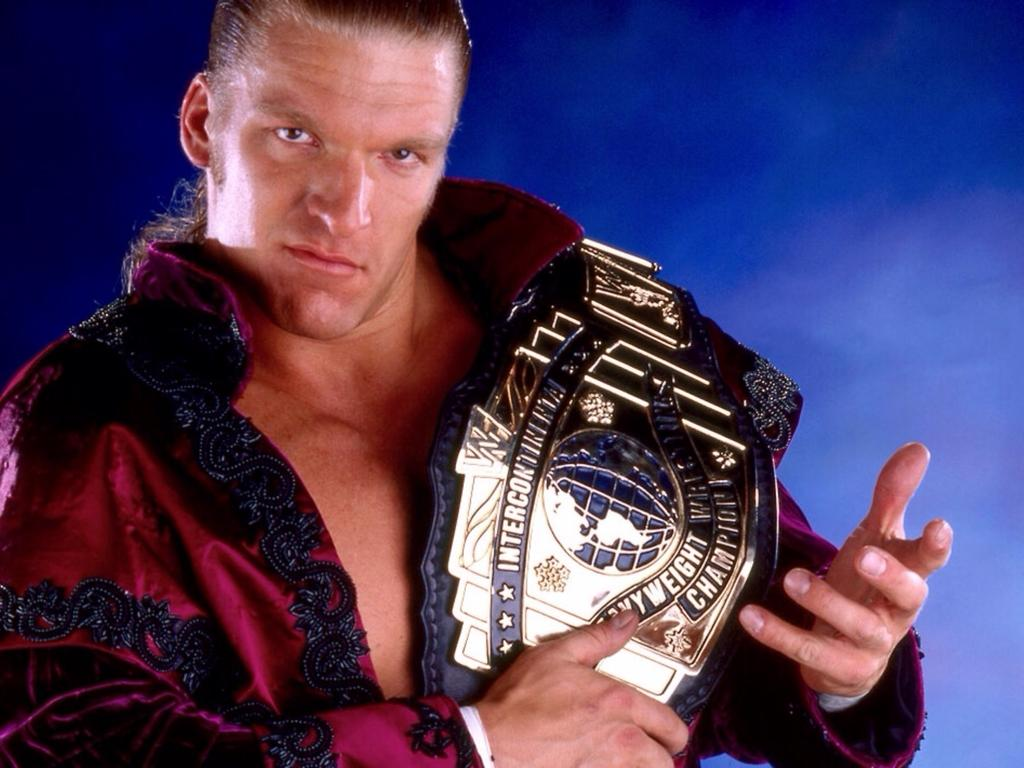Provide a one-sentence caption for the provided image. A professional wrestler is holding the intercontinental heavyweight belt. 